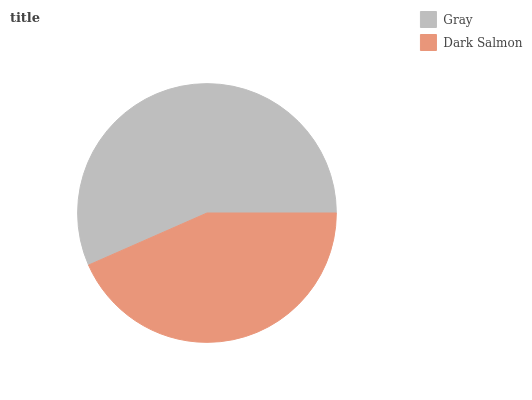Is Dark Salmon the minimum?
Answer yes or no. Yes. Is Gray the maximum?
Answer yes or no. Yes. Is Dark Salmon the maximum?
Answer yes or no. No. Is Gray greater than Dark Salmon?
Answer yes or no. Yes. Is Dark Salmon less than Gray?
Answer yes or no. Yes. Is Dark Salmon greater than Gray?
Answer yes or no. No. Is Gray less than Dark Salmon?
Answer yes or no. No. Is Gray the high median?
Answer yes or no. Yes. Is Dark Salmon the low median?
Answer yes or no. Yes. Is Dark Salmon the high median?
Answer yes or no. No. Is Gray the low median?
Answer yes or no. No. 